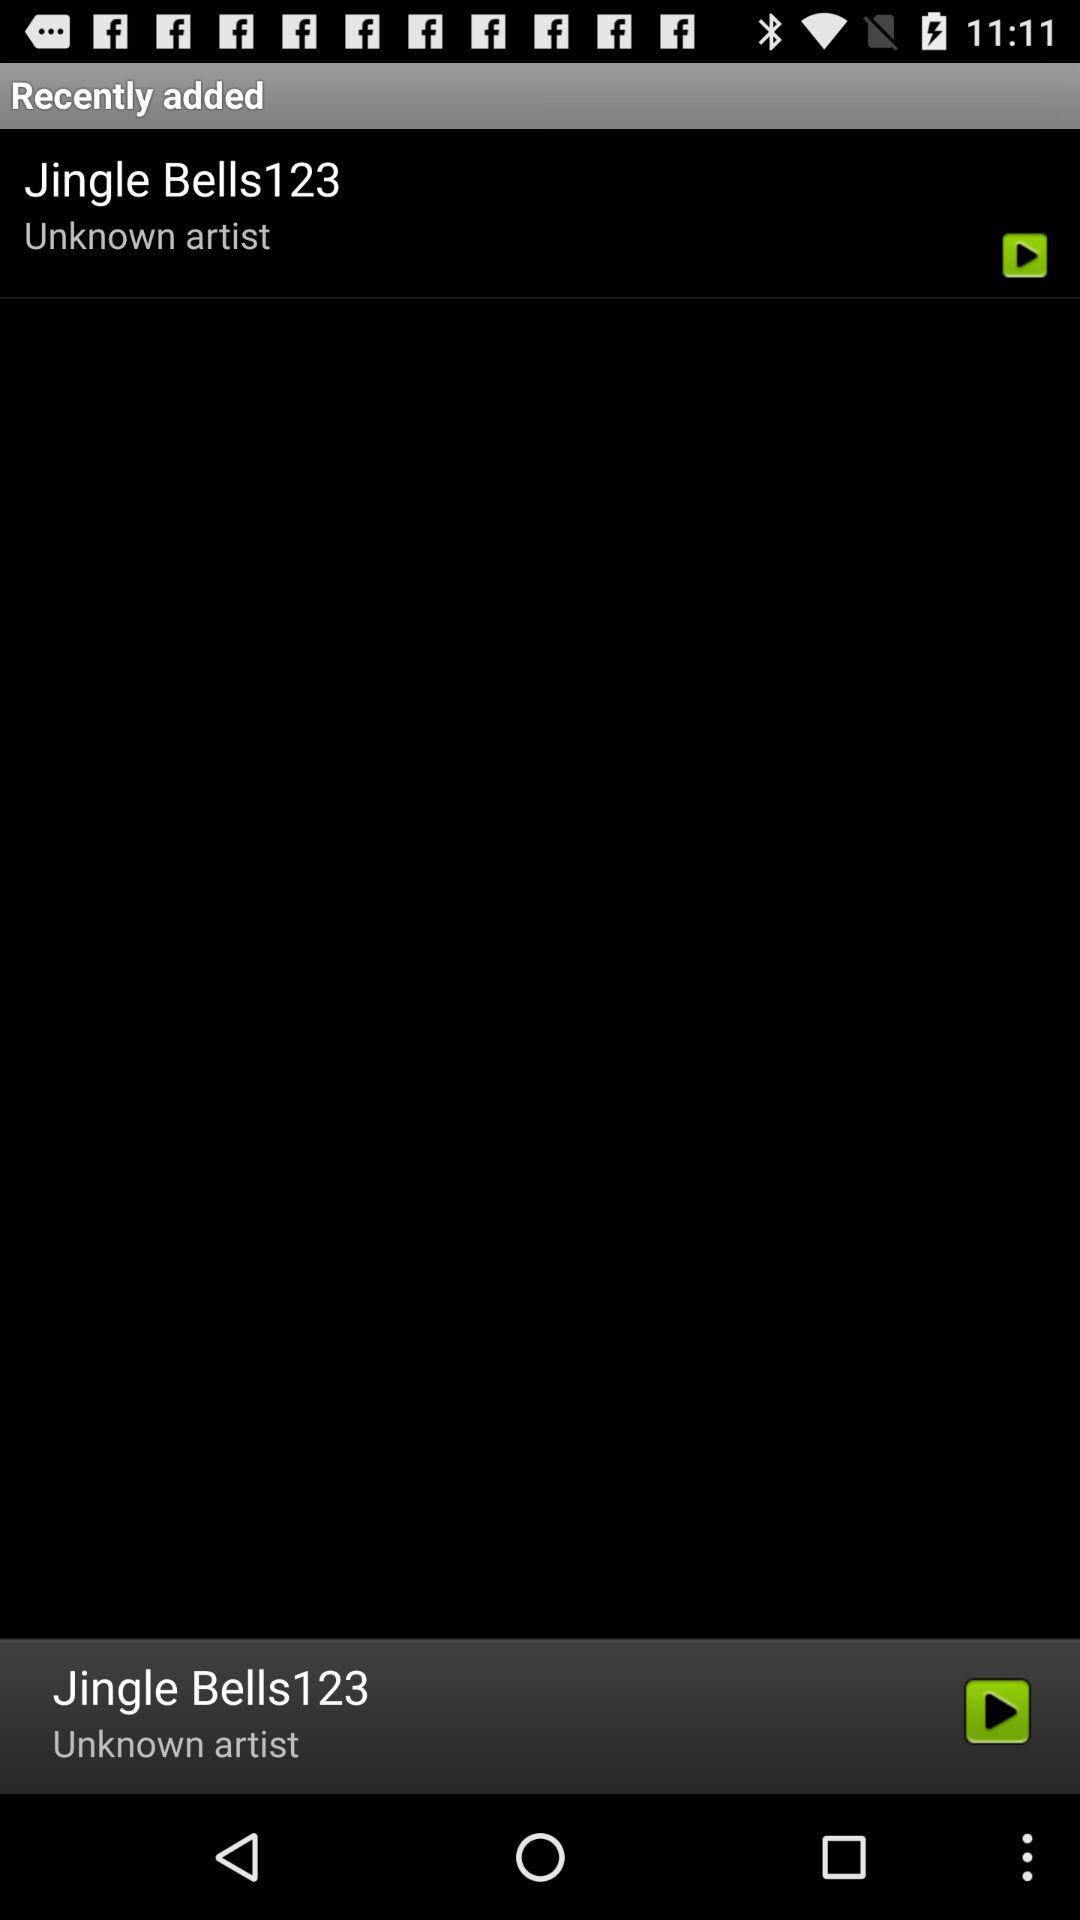Which song is currently playing? The song currently playing is "Jingle Bells123". 